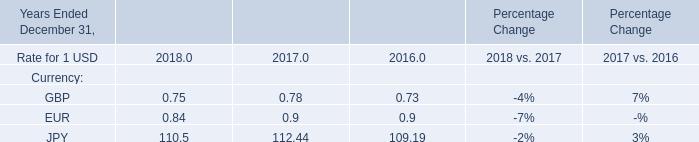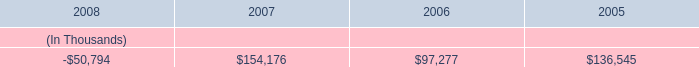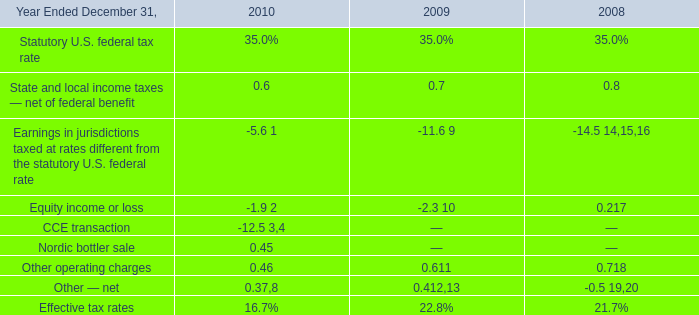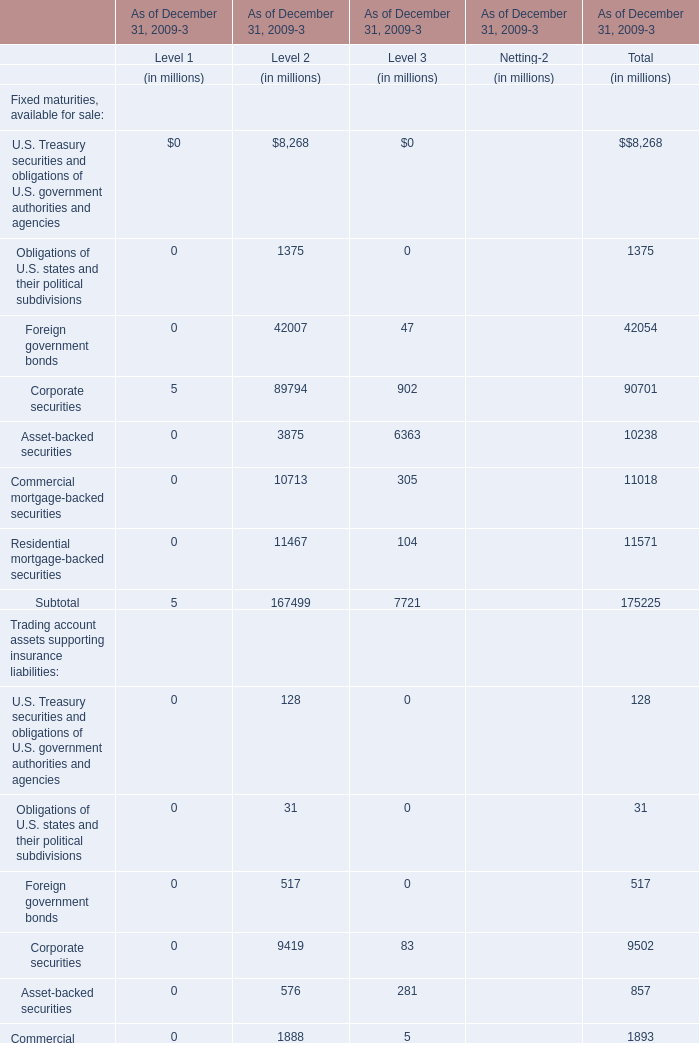how much of entergy gulf states louisiana first mortgage bonds , in millions of dollars , were paid by entergy texas in total? 
Computations: (148.8 + 160.3)
Answer: 309.1. 